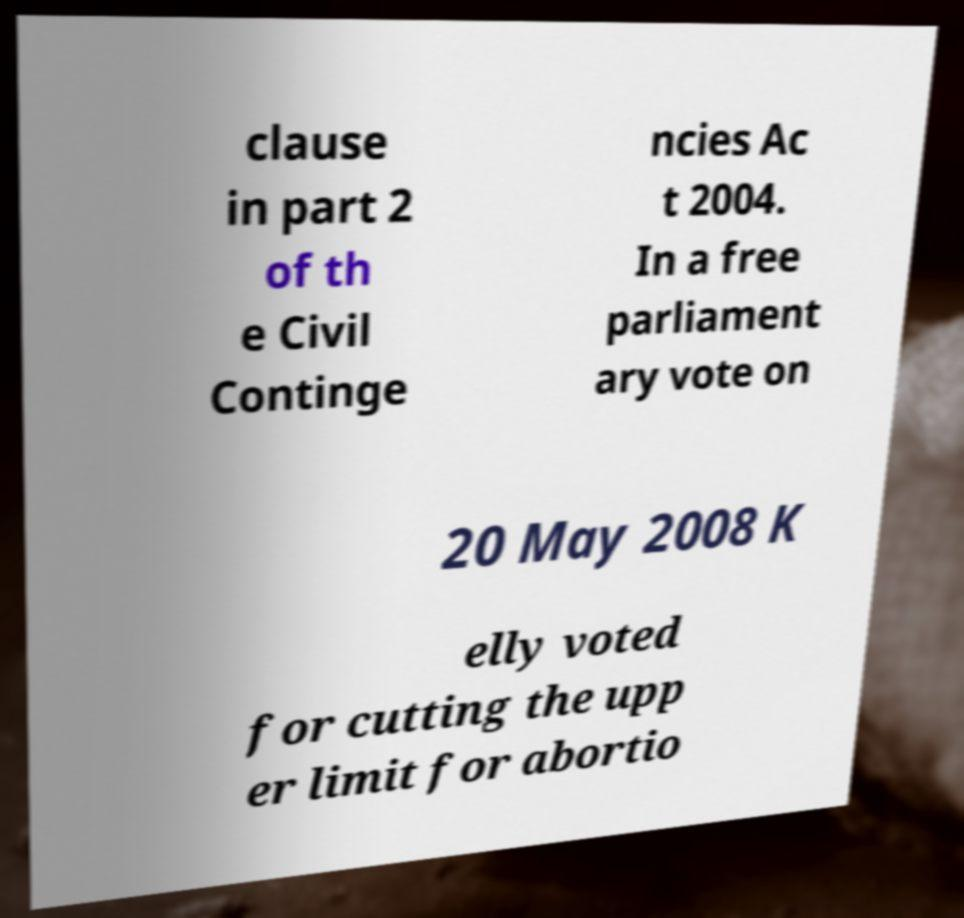What messages or text are displayed in this image? I need them in a readable, typed format. clause in part 2 of th e Civil Continge ncies Ac t 2004. In a free parliament ary vote on 20 May 2008 K elly voted for cutting the upp er limit for abortio 